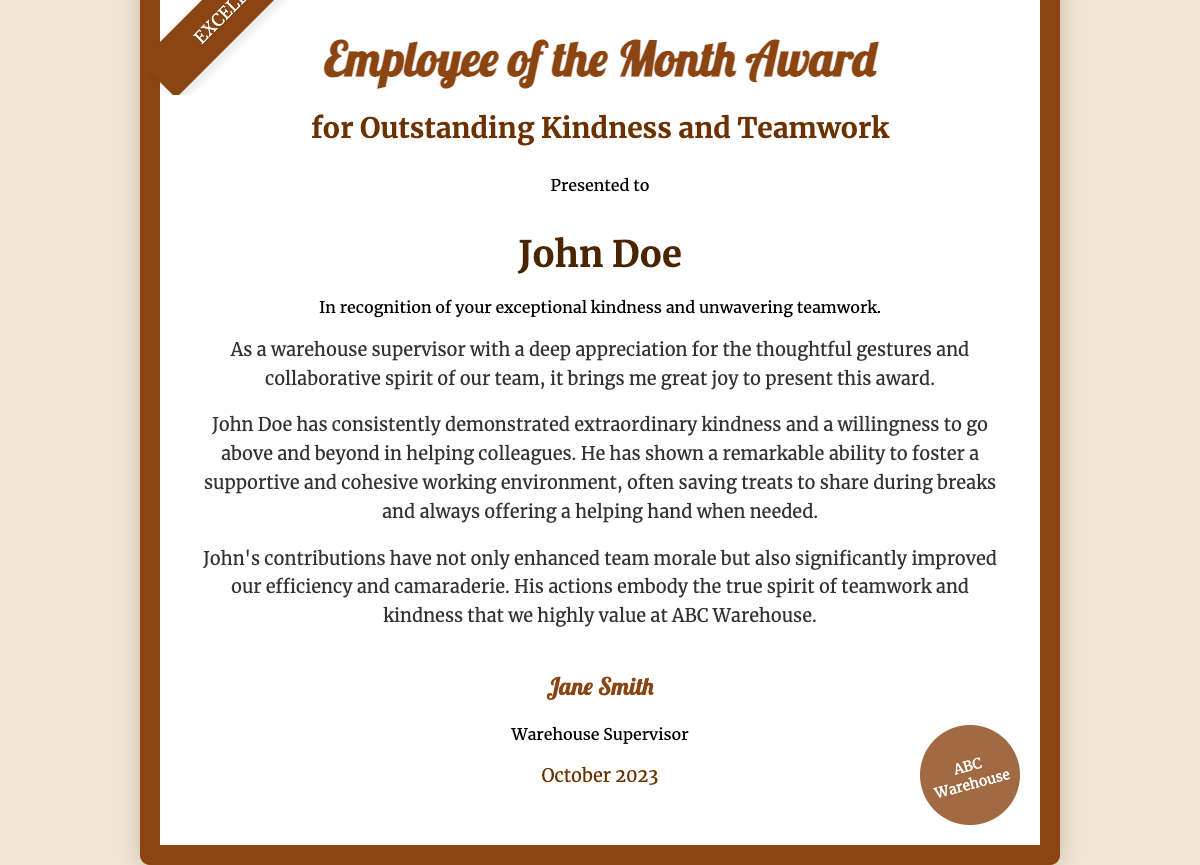What is the name of the award? The award is titled "Employee of the Month Award" as stated at the top of the document.
Answer: Employee of the Month Award Who is the recipient of the award? The document lists "John Doe" as the individual who has received the award.
Answer: John Doe What is the award presented for? The certificate specifies that it is for "Outstanding Kindness and Teamwork."
Answer: Outstanding Kindness and Teamwork Who is the presenter of the award? The award is presented by "Jane Smith," as indicated in the signature section.
Answer: Jane Smith When was the award presented? The date on the certificate is listed as "October 2023."
Answer: October 2023 What qualities did John Doe demonstrate? The document mentions "extraordinary kindness" and "willingness to go above and beyond" as qualities shown by the recipient.
Answer: Extraordinary kindness How does John contribute to team morale? It states that John has "enhanced team morale" and contributed to a supportive working environment.
Answer: Enhanced team morale What company is mentioned on the certificate? The stamp at the bottom of the document indicates that the company is "ABC Warehouse."
Answer: ABC Warehouse 